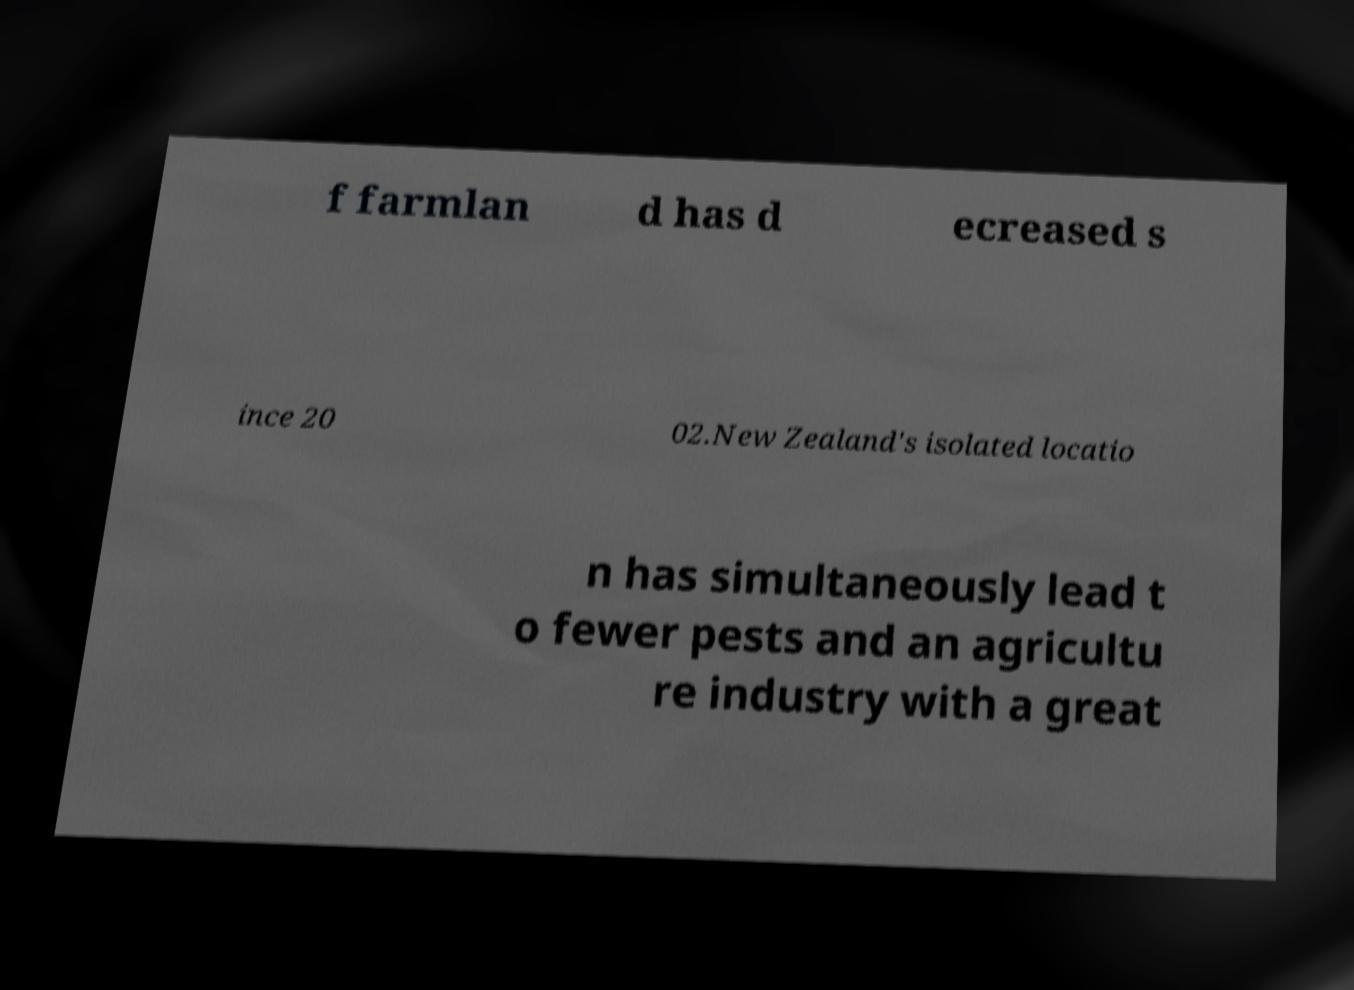Please read and relay the text visible in this image. What does it say? f farmlan d has d ecreased s ince 20 02.New Zealand's isolated locatio n has simultaneously lead t o fewer pests and an agricultu re industry with a great 